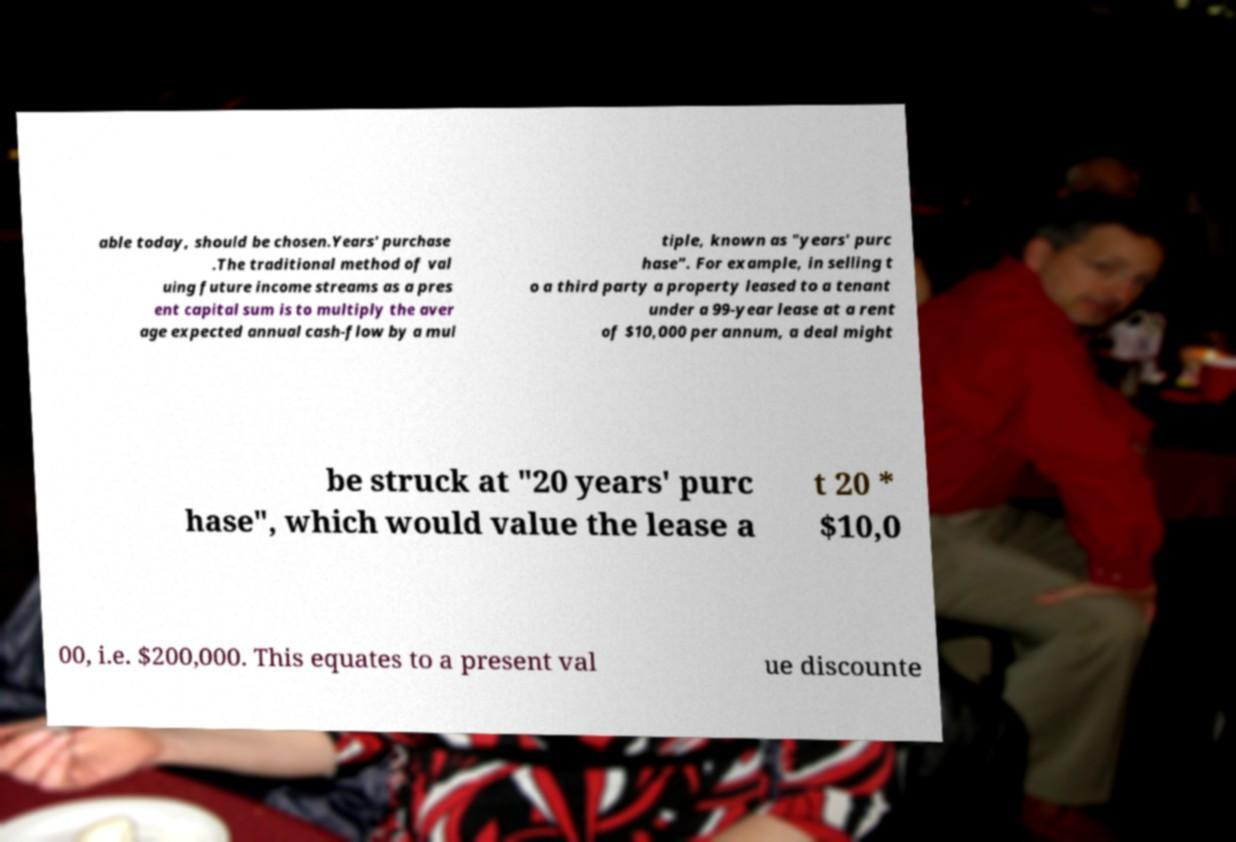There's text embedded in this image that I need extracted. Can you transcribe it verbatim? able today, should be chosen.Years' purchase .The traditional method of val uing future income streams as a pres ent capital sum is to multiply the aver age expected annual cash-flow by a mul tiple, known as "years' purc hase". For example, in selling t o a third party a property leased to a tenant under a 99-year lease at a rent of $10,000 per annum, a deal might be struck at "20 years' purc hase", which would value the lease a t 20 * $10,0 00, i.e. $200,000. This equates to a present val ue discounte 